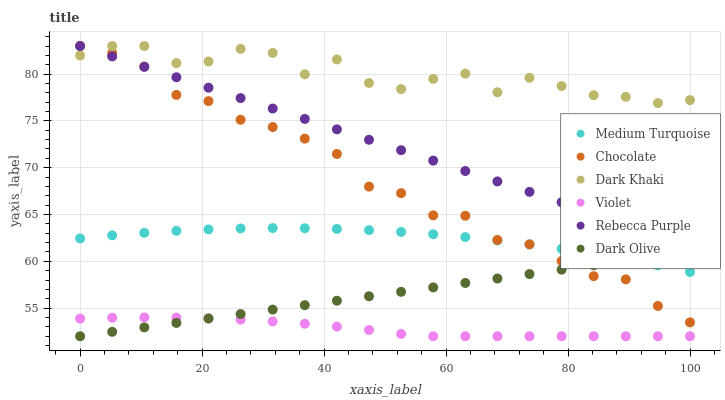Does Violet have the minimum area under the curve?
Answer yes or no. Yes. Does Dark Khaki have the maximum area under the curve?
Answer yes or no. Yes. Does Chocolate have the minimum area under the curve?
Answer yes or no. No. Does Chocolate have the maximum area under the curve?
Answer yes or no. No. Is Dark Olive the smoothest?
Answer yes or no. Yes. Is Dark Khaki the roughest?
Answer yes or no. Yes. Is Chocolate the smoothest?
Answer yes or no. No. Is Chocolate the roughest?
Answer yes or no. No. Does Dark Olive have the lowest value?
Answer yes or no. Yes. Does Chocolate have the lowest value?
Answer yes or no. No. Does Rebecca Purple have the highest value?
Answer yes or no. Yes. Does Medium Turquoise have the highest value?
Answer yes or no. No. Is Dark Olive less than Rebecca Purple?
Answer yes or no. Yes. Is Dark Khaki greater than Medium Turquoise?
Answer yes or no. Yes. Does Medium Turquoise intersect Chocolate?
Answer yes or no. Yes. Is Medium Turquoise less than Chocolate?
Answer yes or no. No. Is Medium Turquoise greater than Chocolate?
Answer yes or no. No. Does Dark Olive intersect Rebecca Purple?
Answer yes or no. No. 